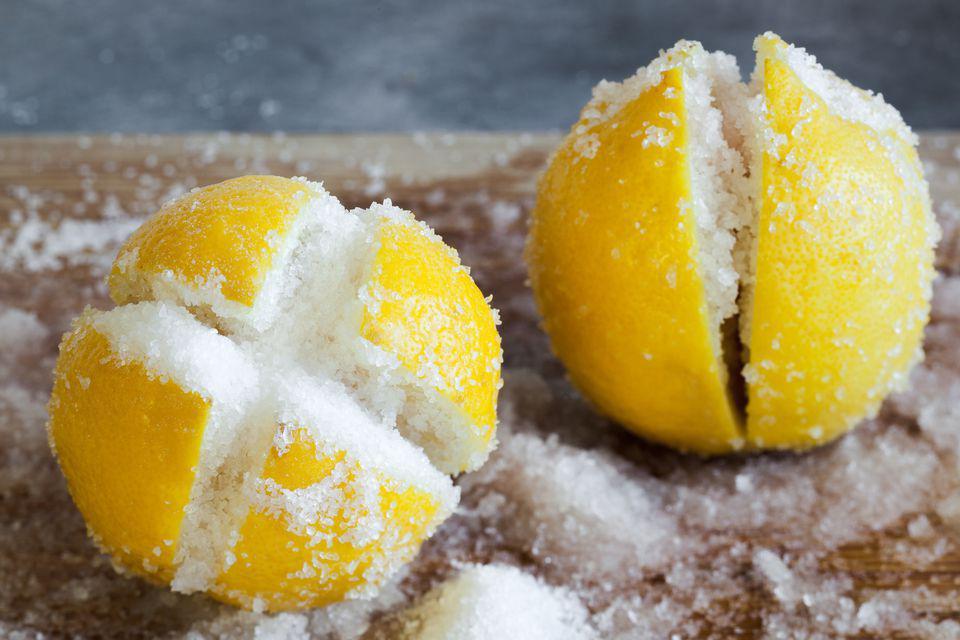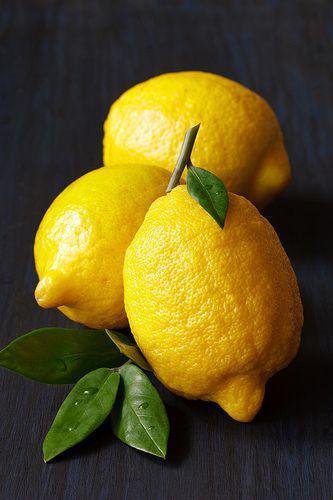The first image is the image on the left, the second image is the image on the right. Analyze the images presented: Is the assertion "The left image contains at least one lemon with a criss-cross cut through the top filled with fine white grains." valid? Answer yes or no. Yes. The first image is the image on the left, the second image is the image on the right. For the images displayed, is the sentence "In at least one image there are a total of four lemon slices." factually correct? Answer yes or no. No. 